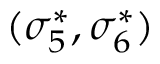Convert formula to latex. <formula><loc_0><loc_0><loc_500><loc_500>( \sigma _ { 5 } ^ { * } , \sigma _ { 6 } ^ { * } )</formula> 